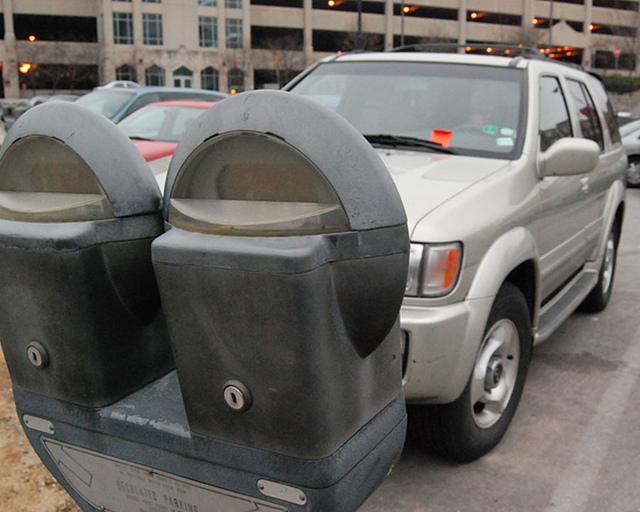Is the car on?
Answer briefly. No. Is this metered parking?
Give a very brief answer. Yes. Is a shadow cast?
Write a very short answer. No. Is this picture taken outside?
Quick response, please. Yes. 